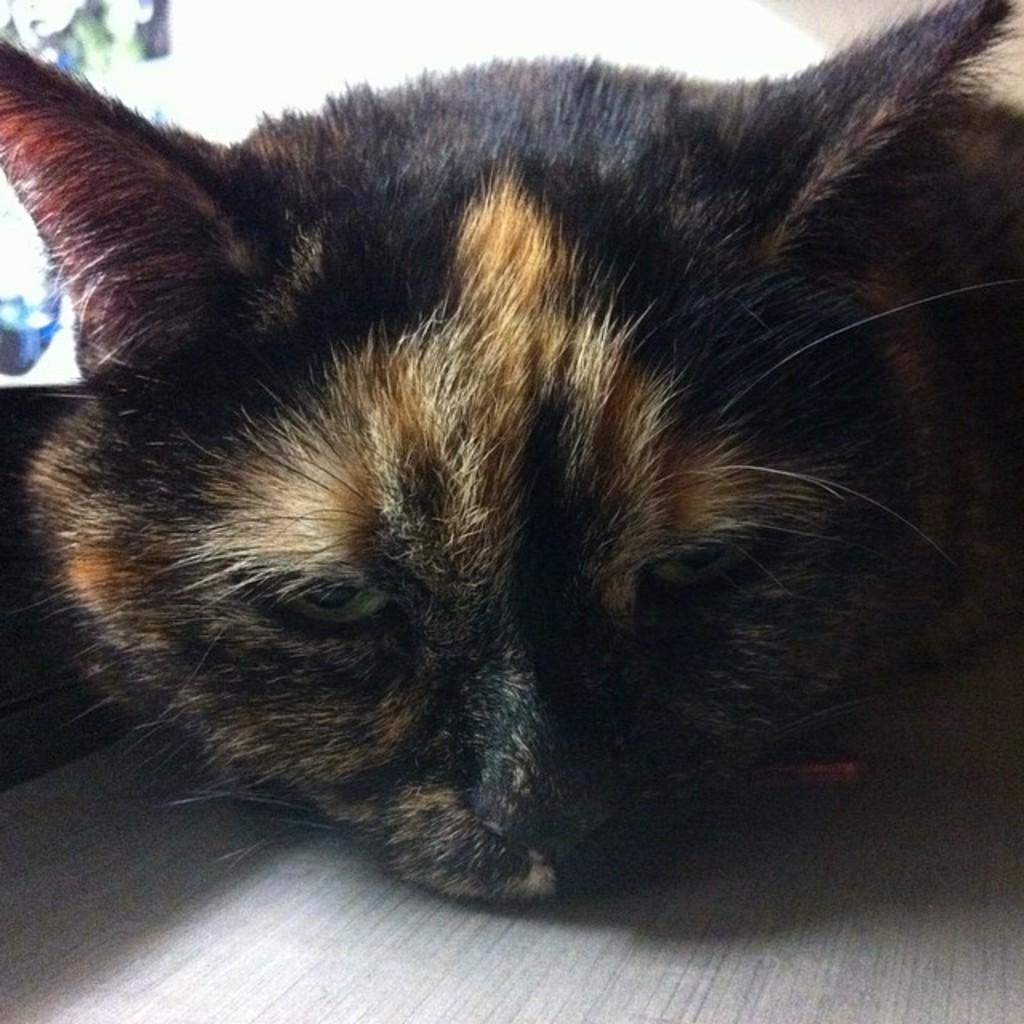How would you summarize this image in a sentence or two? As we can see in the image there is a black color cat and in the background there is a wall. 